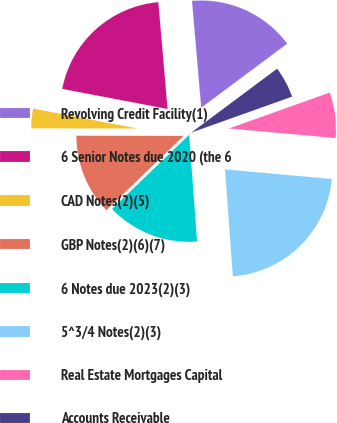Convert chart. <chart><loc_0><loc_0><loc_500><loc_500><pie_chart><fcel>Revolving Credit Facility(1)<fcel>6 Senior Notes due 2020 (the 6<fcel>CAD Notes(2)(5)<fcel>GBP Notes(2)(6)(7)<fcel>6 Notes due 2023(2)(3)<fcel>5^3/4 Notes(2)(3)<fcel>Real Estate Mortgages Capital<fcel>Accounts Receivable<nl><fcel>16.18%<fcel>20.63%<fcel>2.97%<fcel>12.22%<fcel>13.98%<fcel>22.4%<fcel>6.88%<fcel>4.74%<nl></chart> 